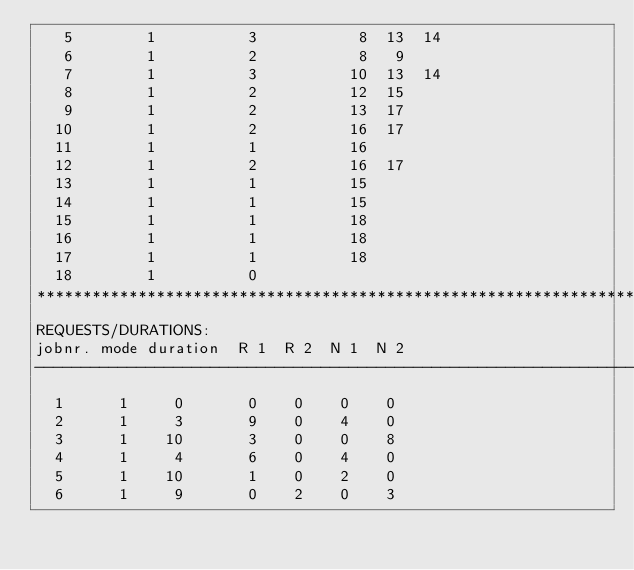Convert code to text. <code><loc_0><loc_0><loc_500><loc_500><_ObjectiveC_>   5        1          3           8  13  14
   6        1          2           8   9
   7        1          3          10  13  14
   8        1          2          12  15
   9        1          2          13  17
  10        1          2          16  17
  11        1          1          16
  12        1          2          16  17
  13        1          1          15
  14        1          1          15
  15        1          1          18
  16        1          1          18
  17        1          1          18
  18        1          0        
************************************************************************
REQUESTS/DURATIONS:
jobnr. mode duration  R 1  R 2  N 1  N 2
------------------------------------------------------------------------
  1      1     0       0    0    0    0
  2      1     3       9    0    4    0
  3      1    10       3    0    0    8
  4      1     4       6    0    4    0
  5      1    10       1    0    2    0
  6      1     9       0    2    0    3</code> 